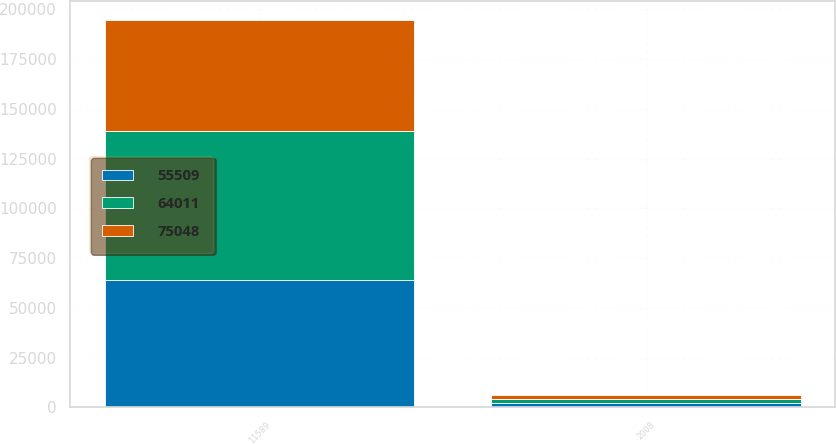Convert chart to OTSL. <chart><loc_0><loc_0><loc_500><loc_500><stacked_bar_chart><ecel><fcel>2008<fcel>11589<nl><fcel>75048<fcel>2007<fcel>55509<nl><fcel>64011<fcel>2006<fcel>75048<nl><fcel>55509<fcel>2005<fcel>64011<nl></chart> 